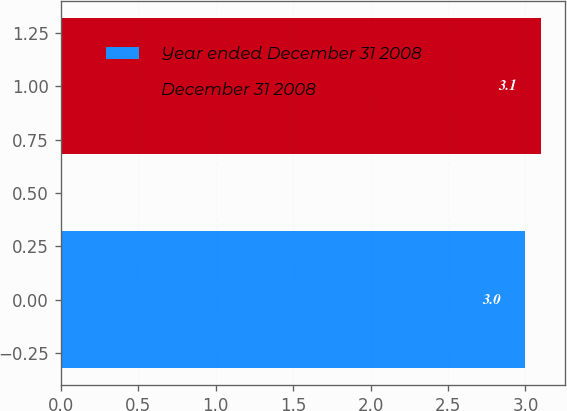<chart> <loc_0><loc_0><loc_500><loc_500><bar_chart><fcel>Year ended December 31 2008<fcel>December 31 2008<nl><fcel>3<fcel>3.1<nl></chart> 